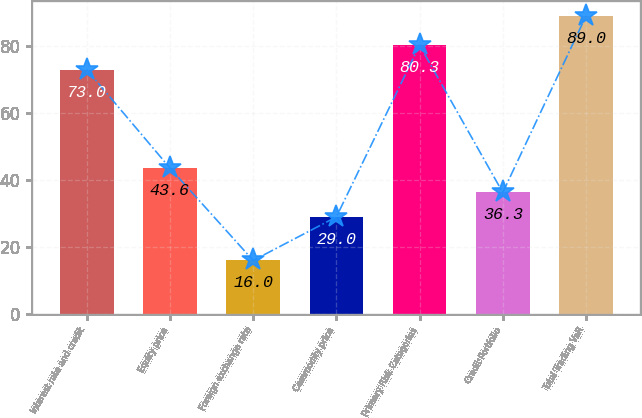<chart> <loc_0><loc_0><loc_500><loc_500><bar_chart><fcel>Interest rate and credit<fcel>Equity price<fcel>Foreign exchange rate<fcel>Commodity price<fcel>Primary Risk Categories<fcel>Credit Portfolio<fcel>Total Trading VaR<nl><fcel>73<fcel>43.6<fcel>16<fcel>29<fcel>80.3<fcel>36.3<fcel>89<nl></chart> 